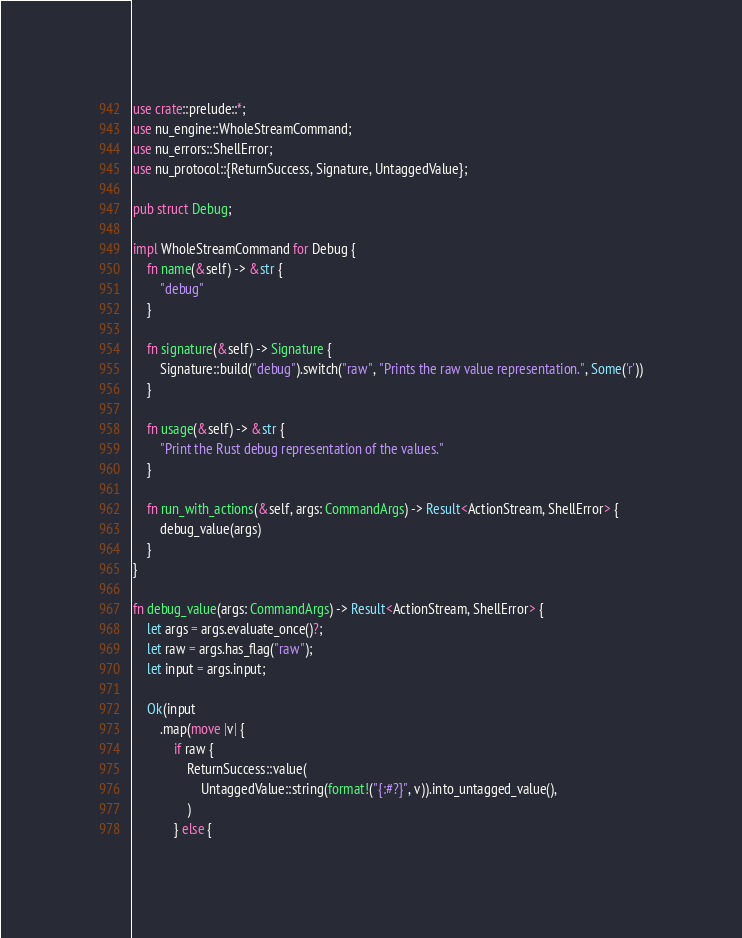<code> <loc_0><loc_0><loc_500><loc_500><_Rust_>use crate::prelude::*;
use nu_engine::WholeStreamCommand;
use nu_errors::ShellError;
use nu_protocol::{ReturnSuccess, Signature, UntaggedValue};

pub struct Debug;

impl WholeStreamCommand for Debug {
    fn name(&self) -> &str {
        "debug"
    }

    fn signature(&self) -> Signature {
        Signature::build("debug").switch("raw", "Prints the raw value representation.", Some('r'))
    }

    fn usage(&self) -> &str {
        "Print the Rust debug representation of the values."
    }

    fn run_with_actions(&self, args: CommandArgs) -> Result<ActionStream, ShellError> {
        debug_value(args)
    }
}

fn debug_value(args: CommandArgs) -> Result<ActionStream, ShellError> {
    let args = args.evaluate_once()?;
    let raw = args.has_flag("raw");
    let input = args.input;

    Ok(input
        .map(move |v| {
            if raw {
                ReturnSuccess::value(
                    UntaggedValue::string(format!("{:#?}", v)).into_untagged_value(),
                )
            } else {</code> 